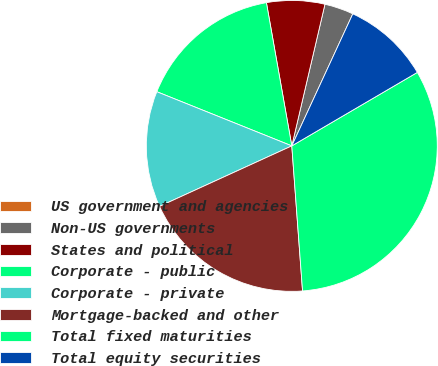Convert chart. <chart><loc_0><loc_0><loc_500><loc_500><pie_chart><fcel>US government and agencies<fcel>Non-US governments<fcel>States and political<fcel>Corporate - public<fcel>Corporate - private<fcel>Mortgage-backed and other<fcel>Total fixed maturities<fcel>Total equity securities<nl><fcel>0.0%<fcel>3.23%<fcel>6.45%<fcel>16.13%<fcel>12.9%<fcel>19.35%<fcel>32.25%<fcel>9.68%<nl></chart> 